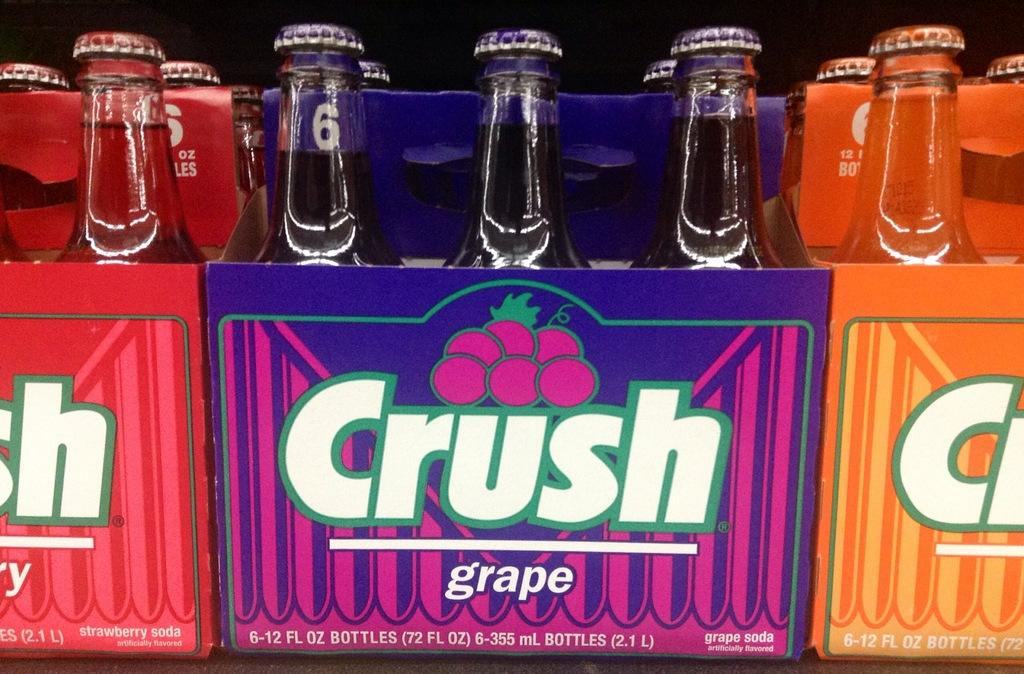<image>
Create a compact narrative representing the image presented. Packs of crush grape soda in a twelve ounce bottle 